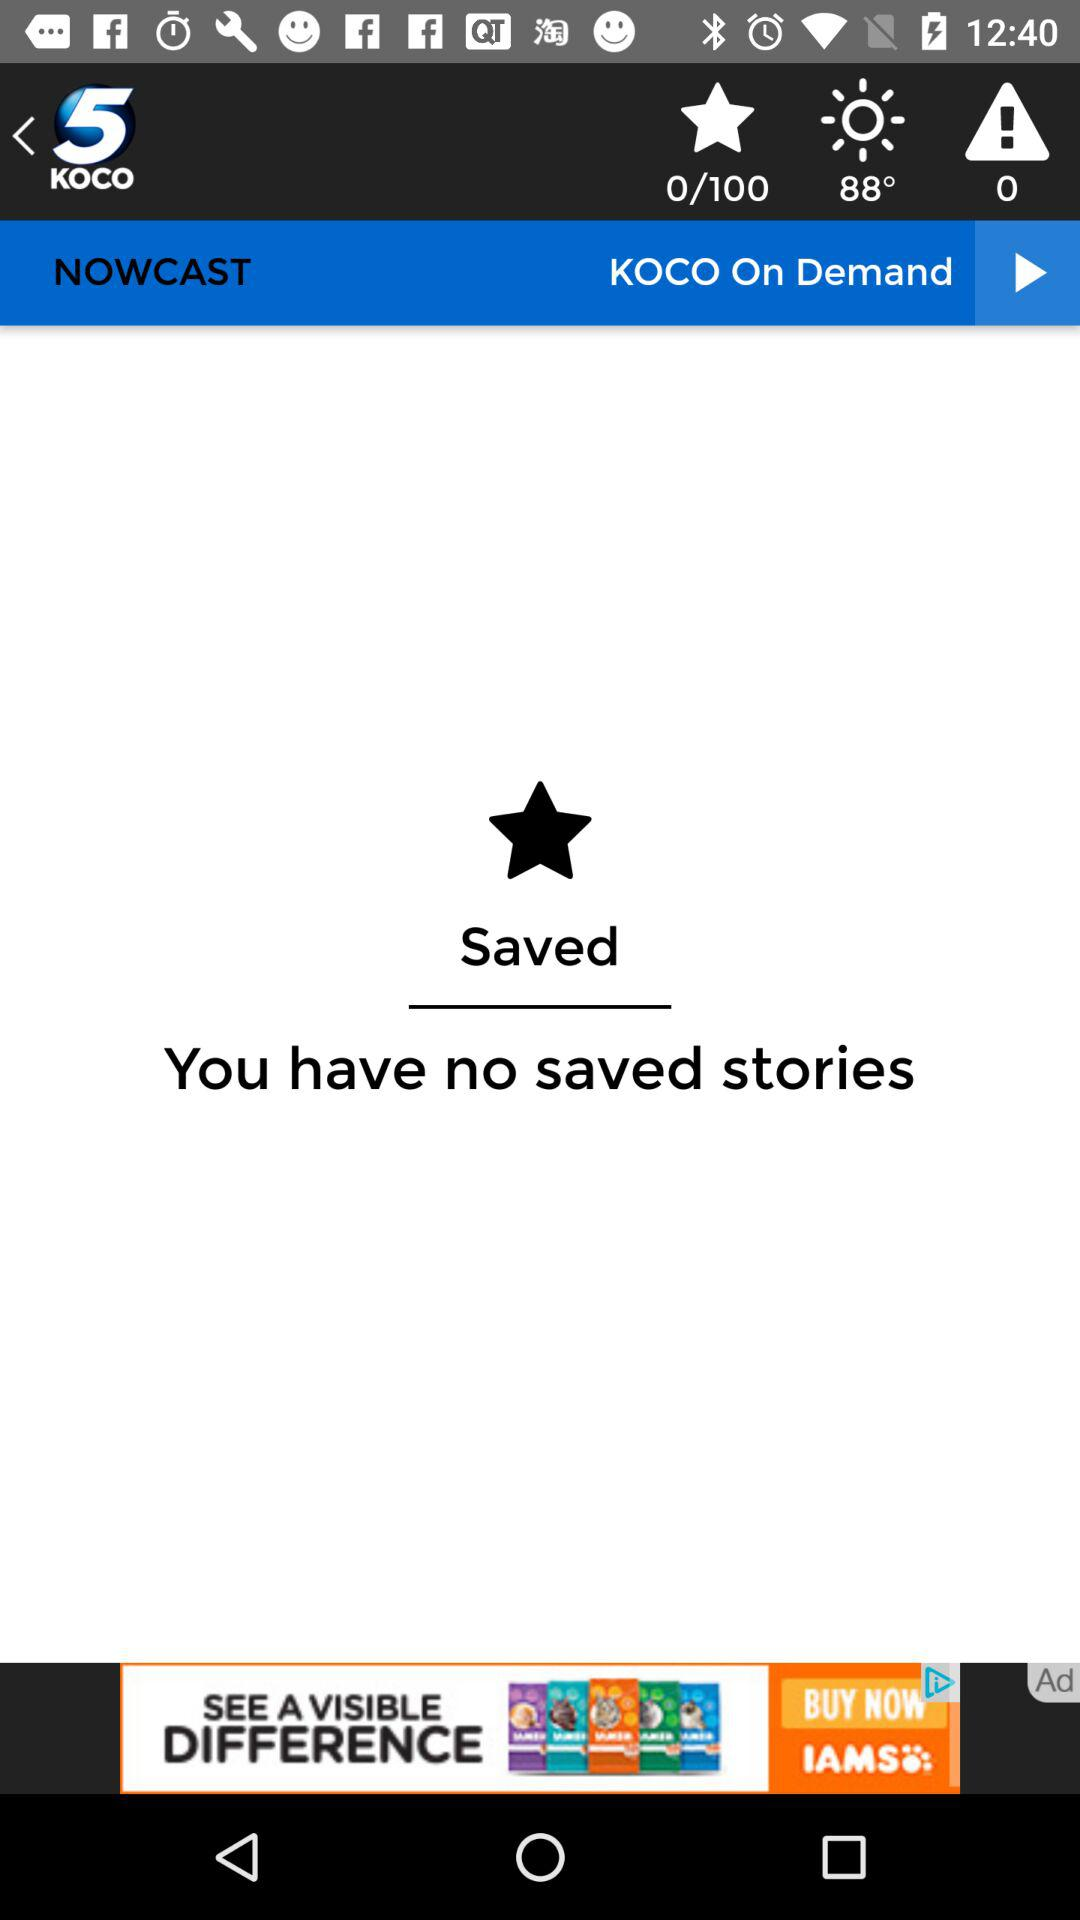How many saved stories do I have?
Answer the question using a single word or phrase. 0 